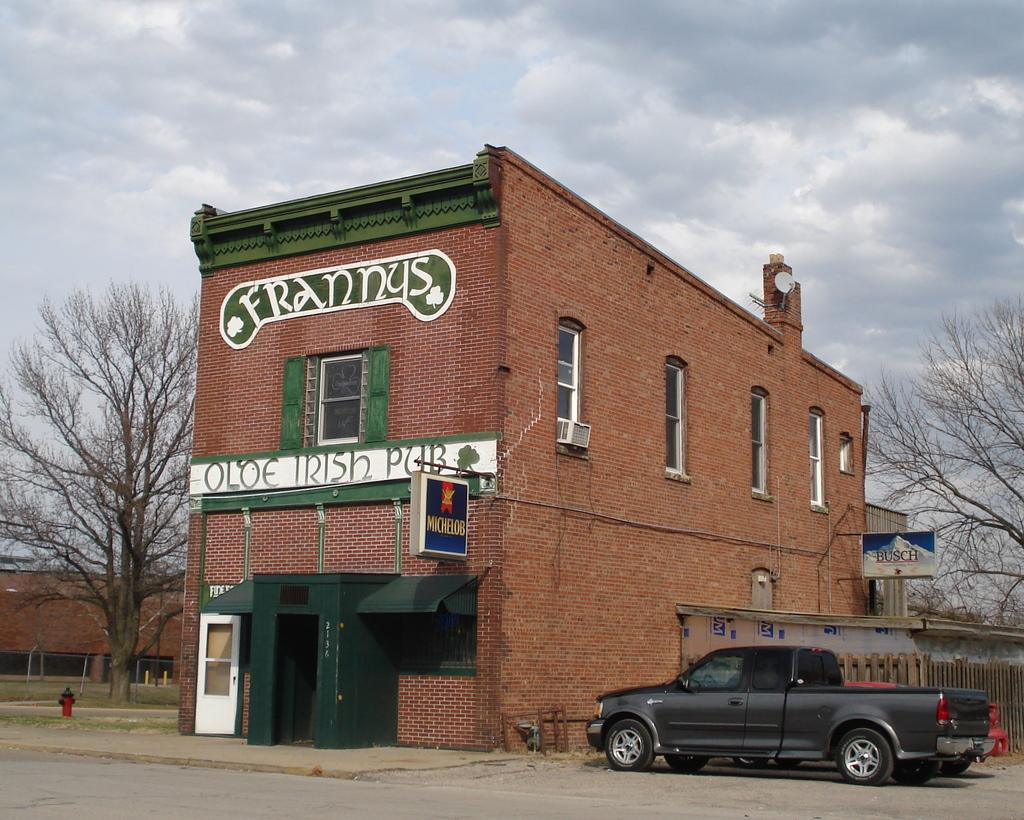What type of structures can be seen in the image? There are buildings in the image. What natural elements are present in the image? There are trees in the image. What is located beside the building? There is a fence beside the building. What type of vehicles are visible in the image? There are cars in the image. What type of signage is present in the image? There are hoardings in the image. Can you describe the presence of a person in the image? There is a person in the background of the image. What type of bread is being used in the fight depicted in the image? There is no fight or bread present in the image. 